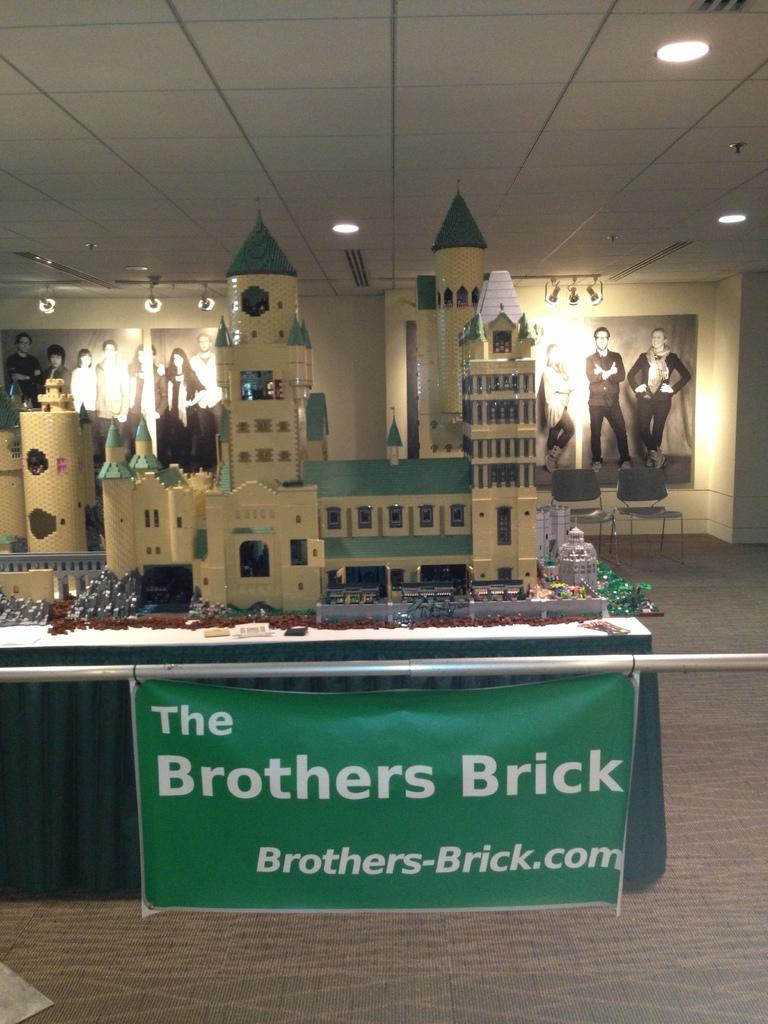<image>
Summarize the visual content of the image. a castle model on display on a table with a sign reading the brothers brick 